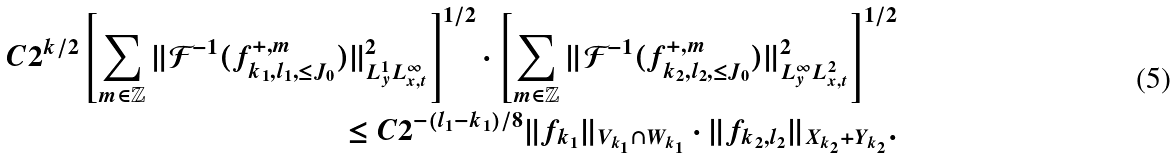<formula> <loc_0><loc_0><loc_500><loc_500>C 2 ^ { k / 2 } \left [ \sum _ { m \in \mathbb { Z } } \| \mathcal { F } ^ { - 1 } ( f _ { k _ { 1 } , l _ { 1 } , \leq J _ { 0 } } ^ { + , m } ) \| _ { L ^ { 1 } _ { y } L ^ { \infty } _ { x , t } } ^ { 2 } \right ] ^ { 1 / 2 } \cdot \left [ \sum _ { m \in \mathbb { Z } } \| \mathcal { F } ^ { - 1 } ( f _ { k _ { 2 } , l _ { 2 } , \leq J _ { 0 } } ^ { + , m } ) \| _ { L ^ { \infty } _ { y } L ^ { 2 } _ { x , t } } ^ { 2 } \right ] ^ { 1 / 2 } \\ \leq C 2 ^ { - ( l _ { 1 } - k _ { 1 } ) / 8 } \| f _ { k _ { 1 } } \| _ { V _ { k _ { 1 } } \cap W _ { k _ { 1 } } } \cdot \| f _ { k _ { 2 } , l _ { 2 } } \| _ { X _ { k _ { 2 } } + Y _ { k _ { 2 } } } .</formula> 